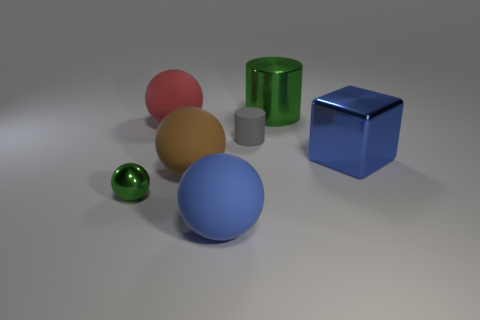Do the objects appear to be in any specific order or pattern? The objects do not seem to follow any specific order or pattern. They are arranged randomly with varying sizes and distances between them, suggesting no deliberate organization. 